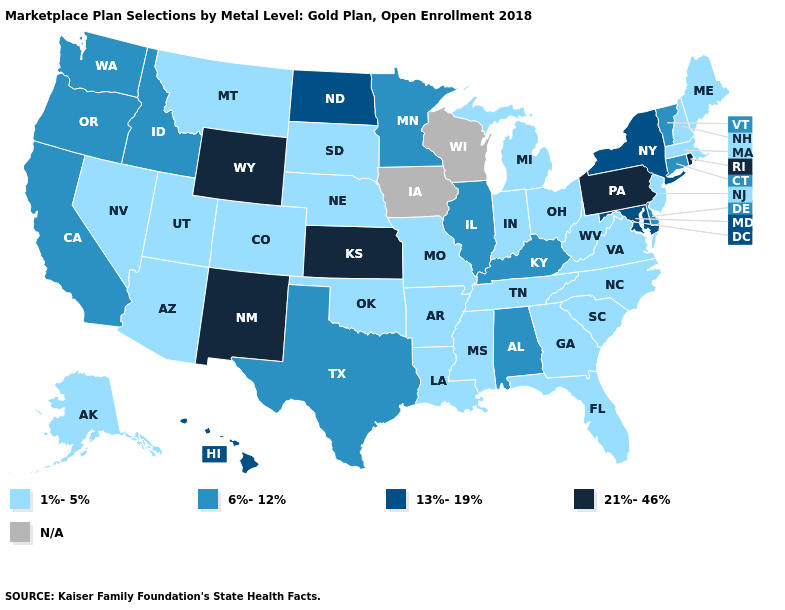Which states hav the highest value in the West?
Answer briefly. New Mexico, Wyoming. Does the map have missing data?
Short answer required. Yes. Name the states that have a value in the range N/A?
Quick response, please. Iowa, Wisconsin. Does the first symbol in the legend represent the smallest category?
Be succinct. Yes. Does the first symbol in the legend represent the smallest category?
Answer briefly. Yes. Does the map have missing data?
Keep it brief. Yes. Among the states that border Idaho , which have the highest value?
Give a very brief answer. Wyoming. Name the states that have a value in the range 6%-12%?
Answer briefly. Alabama, California, Connecticut, Delaware, Idaho, Illinois, Kentucky, Minnesota, Oregon, Texas, Vermont, Washington. What is the value of Washington?
Short answer required. 6%-12%. Name the states that have a value in the range N/A?
Give a very brief answer. Iowa, Wisconsin. What is the highest value in the West ?
Write a very short answer. 21%-46%. What is the value of Texas?
Keep it brief. 6%-12%. 